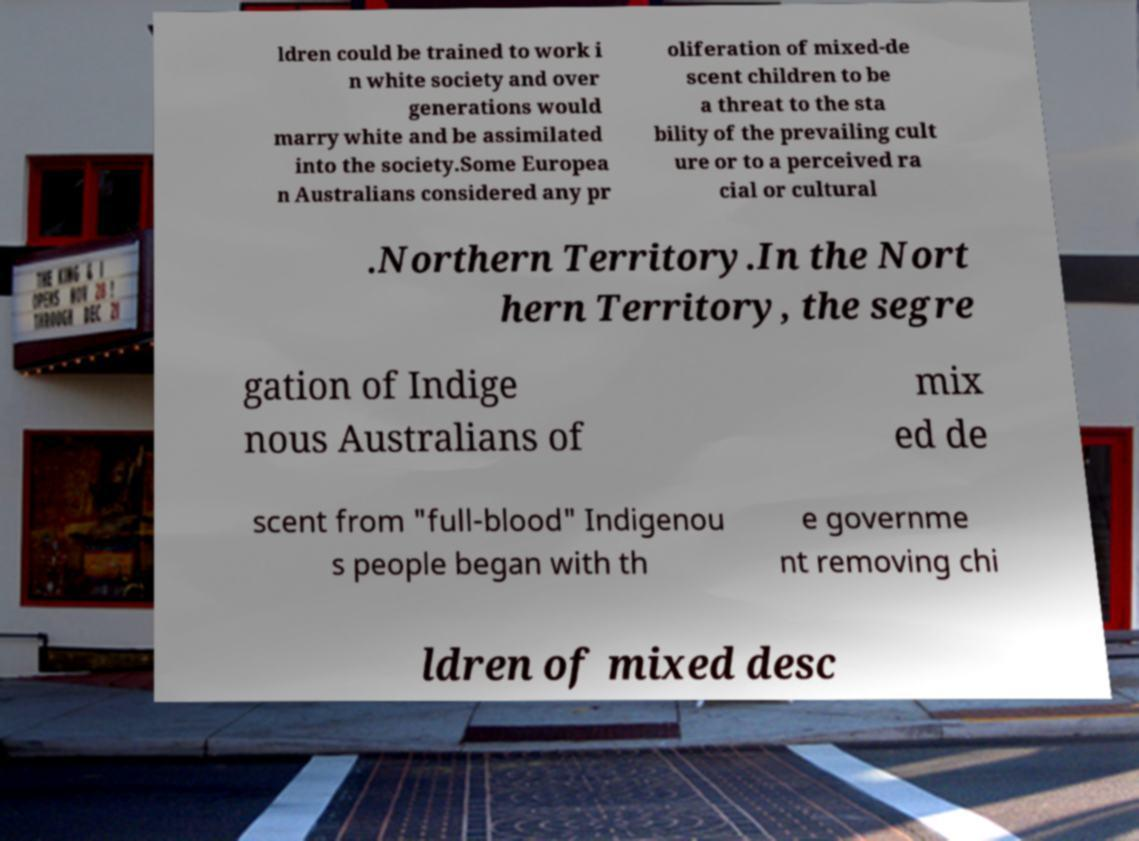Can you accurately transcribe the text from the provided image for me? ldren could be trained to work i n white society and over generations would marry white and be assimilated into the society.Some Europea n Australians considered any pr oliferation of mixed-de scent children to be a threat to the sta bility of the prevailing cult ure or to a perceived ra cial or cultural .Northern Territory.In the Nort hern Territory, the segre gation of Indige nous Australians of mix ed de scent from "full-blood" Indigenou s people began with th e governme nt removing chi ldren of mixed desc 